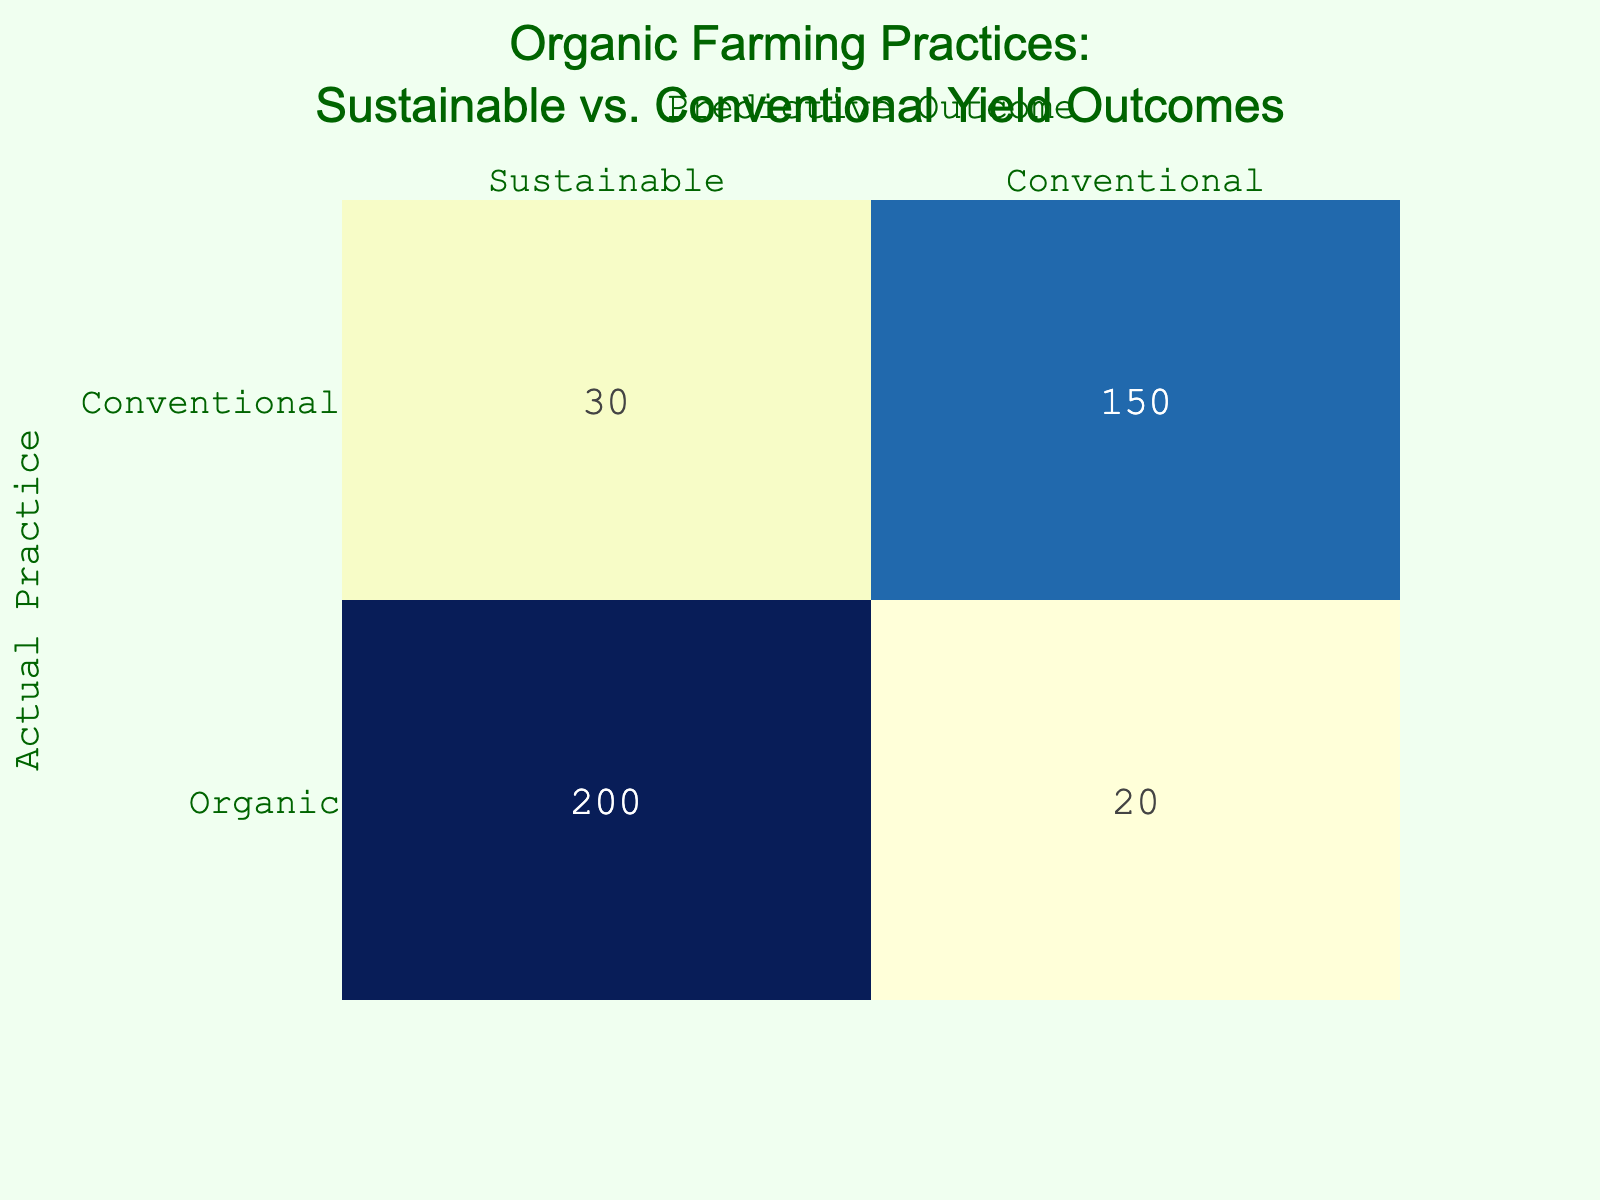What is the count of predicted outcomes for organic farming that resulted in conventional yield? Referring directly to the table, the cell that corresponds to "Organic" practice and "Conventional" outcome shows the count as 30.
Answer: 30 What is the total count of outcomes for conventional farming practices? To find this, I look at the two relevant rows for "Conventional" farming practice: Conventional/Sustainable (20) and Conventional/Conventional (200). Adding these gives us 20 + 200 = 220.
Answer: 220 Is the predicted outcome of sustainable yield higher for organic or conventional farming practices? We compare the counts. For organic farming, the sustainable yield was 150, while for conventional, it was only 20. Since 150 is greater than 20, organic farming had a higher sustainable yield outcome.
Answer: Yes What is the difference in count between the predicted outcomes of sustainable yields for organic and conventional practices? The sustainable yield for organic farming is 150, and for conventional farming, it is 20. The difference is calculated as 150 - 20 = 130.
Answer: 130 What percentage of organic farming outcomes predicted a sustainable yield? The total outcomes related to organic farming are 150 (sustainable) + 30 (conventional) = 180. The sustainable outcomes comprise 150 of these. To calculate the percentage: (150/180) * 100 = 83.33%.
Answer: 83.33% What is the total count of all outcomes from both organic and conventional farming practices combined? By summing all the counts: 150 (organic sustainable) + 30 (organic conventional) + 20 (conventional sustainable) + 200 (conventional conventional) = 400 total outcomes.
Answer: 400 Do organic farming practices tend to lead to higher yield predictions than conventional practices when combined? From the table, the total for organic sustainable outcomes (150) plus organic conventional (30) is 180. The total for conventional sustainable (20) plus conventional conventional (200) is 220. Because 180 is less than 220, organic farming practices do not lead to higher yield predictions overall.
Answer: No What has a higher total yield, sustainable or conventional outcomes across both practices? Sum the sustainable outcomes (150 from organic and 20 from conventional) to get 170. For conventional outcomes, (30 from organic and 200 from conventional) gives us 230. Since 170 is less than 230, conventional outcomes have a higher total yield.
Answer: Conventional outcomes 